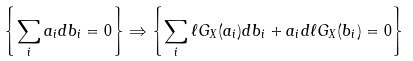<formula> <loc_0><loc_0><loc_500><loc_500>\left \{ \sum _ { i } a _ { i } d b _ { i } = 0 \right \} \Rightarrow \left \{ \sum _ { i } \ell G _ { X } ( a _ { i } ) d b _ { i } + a _ { i } d \ell G _ { X } ( b _ { i } ) = 0 \right \}</formula> 